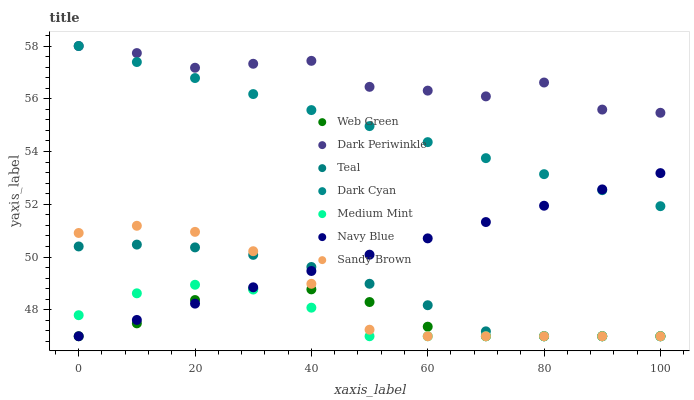Does Medium Mint have the minimum area under the curve?
Answer yes or no. Yes. Does Dark Periwinkle have the maximum area under the curve?
Answer yes or no. Yes. Does Navy Blue have the minimum area under the curve?
Answer yes or no. No. Does Navy Blue have the maximum area under the curve?
Answer yes or no. No. Is Navy Blue the smoothest?
Answer yes or no. Yes. Is Dark Periwinkle the roughest?
Answer yes or no. Yes. Is Web Green the smoothest?
Answer yes or no. No. Is Web Green the roughest?
Answer yes or no. No. Does Medium Mint have the lowest value?
Answer yes or no. Yes. Does Dark Cyan have the lowest value?
Answer yes or no. No. Does Dark Periwinkle have the highest value?
Answer yes or no. Yes. Does Navy Blue have the highest value?
Answer yes or no. No. Is Teal less than Dark Periwinkle?
Answer yes or no. Yes. Is Dark Cyan greater than Medium Mint?
Answer yes or no. Yes. Does Dark Cyan intersect Dark Periwinkle?
Answer yes or no. Yes. Is Dark Cyan less than Dark Periwinkle?
Answer yes or no. No. Is Dark Cyan greater than Dark Periwinkle?
Answer yes or no. No. Does Teal intersect Dark Periwinkle?
Answer yes or no. No. 